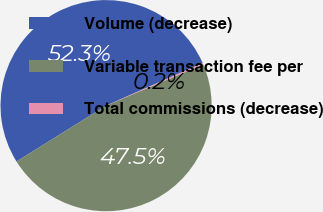Convert chart to OTSL. <chart><loc_0><loc_0><loc_500><loc_500><pie_chart><fcel>Volume (decrease)<fcel>Variable transaction fee per<fcel>Total commissions (decrease)<nl><fcel>52.26%<fcel>47.51%<fcel>0.23%<nl></chart> 